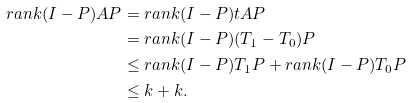Convert formula to latex. <formula><loc_0><loc_0><loc_500><loc_500>r a n k ( I - P ) A P & = r a n k ( I - P ) t A P \\ & = r a n k ( I - P ) ( T _ { 1 } - T _ { 0 } ) P \\ & \leq r a n k ( I - P ) T _ { 1 } P + r a n k ( I - P ) T _ { 0 } P \\ & \leq k + k .</formula> 